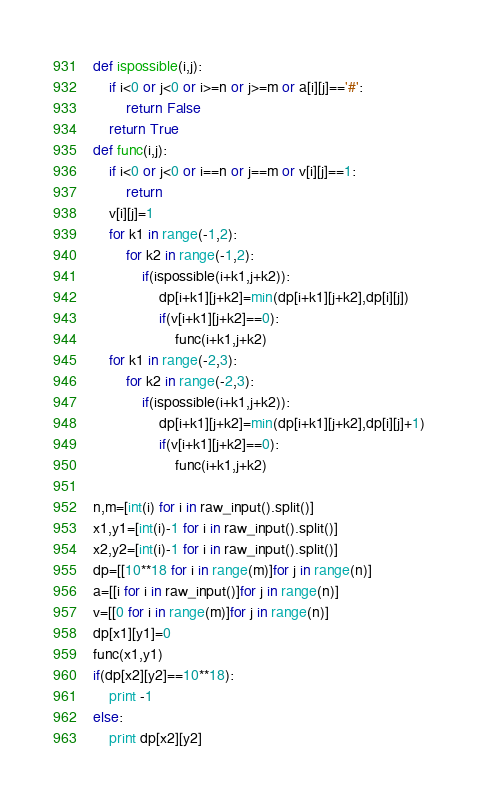Convert code to text. <code><loc_0><loc_0><loc_500><loc_500><_Python_>def ispossible(i,j):
    if i<0 or j<0 or i>=n or j>=m or a[i][j]=='#':
        return False
    return True
def func(i,j):
    if i<0 or j<0 or i==n or j==m or v[i][j]==1:
        return
    v[i][j]=1
    for k1 in range(-1,2):
        for k2 in range(-1,2):
            if(ispossible(i+k1,j+k2)):
                dp[i+k1][j+k2]=min(dp[i+k1][j+k2],dp[i][j])
                if(v[i+k1][j+k2]==0):
                    func(i+k1,j+k2)
    for k1 in range(-2,3):
        for k2 in range(-2,3):
            if(ispossible(i+k1,j+k2)):
                dp[i+k1][j+k2]=min(dp[i+k1][j+k2],dp[i][j]+1)
                if(v[i+k1][j+k2]==0):
                    func(i+k1,j+k2)
    
n,m=[int(i) for i in raw_input().split()]
x1,y1=[int(i)-1 for i in raw_input().split()]
x2,y2=[int(i)-1 for i in raw_input().split()]
dp=[[10**18 for i in range(m)]for j in range(n)]
a=[[i for i in raw_input()]for j in range(n)]
v=[[0 for i in range(m)]for j in range(n)]
dp[x1][y1]=0
func(x1,y1)
if(dp[x2][y2]==10**18):
    print -1
else:
    print dp[x2][y2]
</code> 